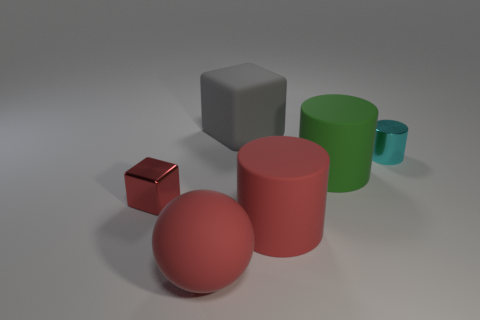Are there any spheres that have the same material as the small block? no 